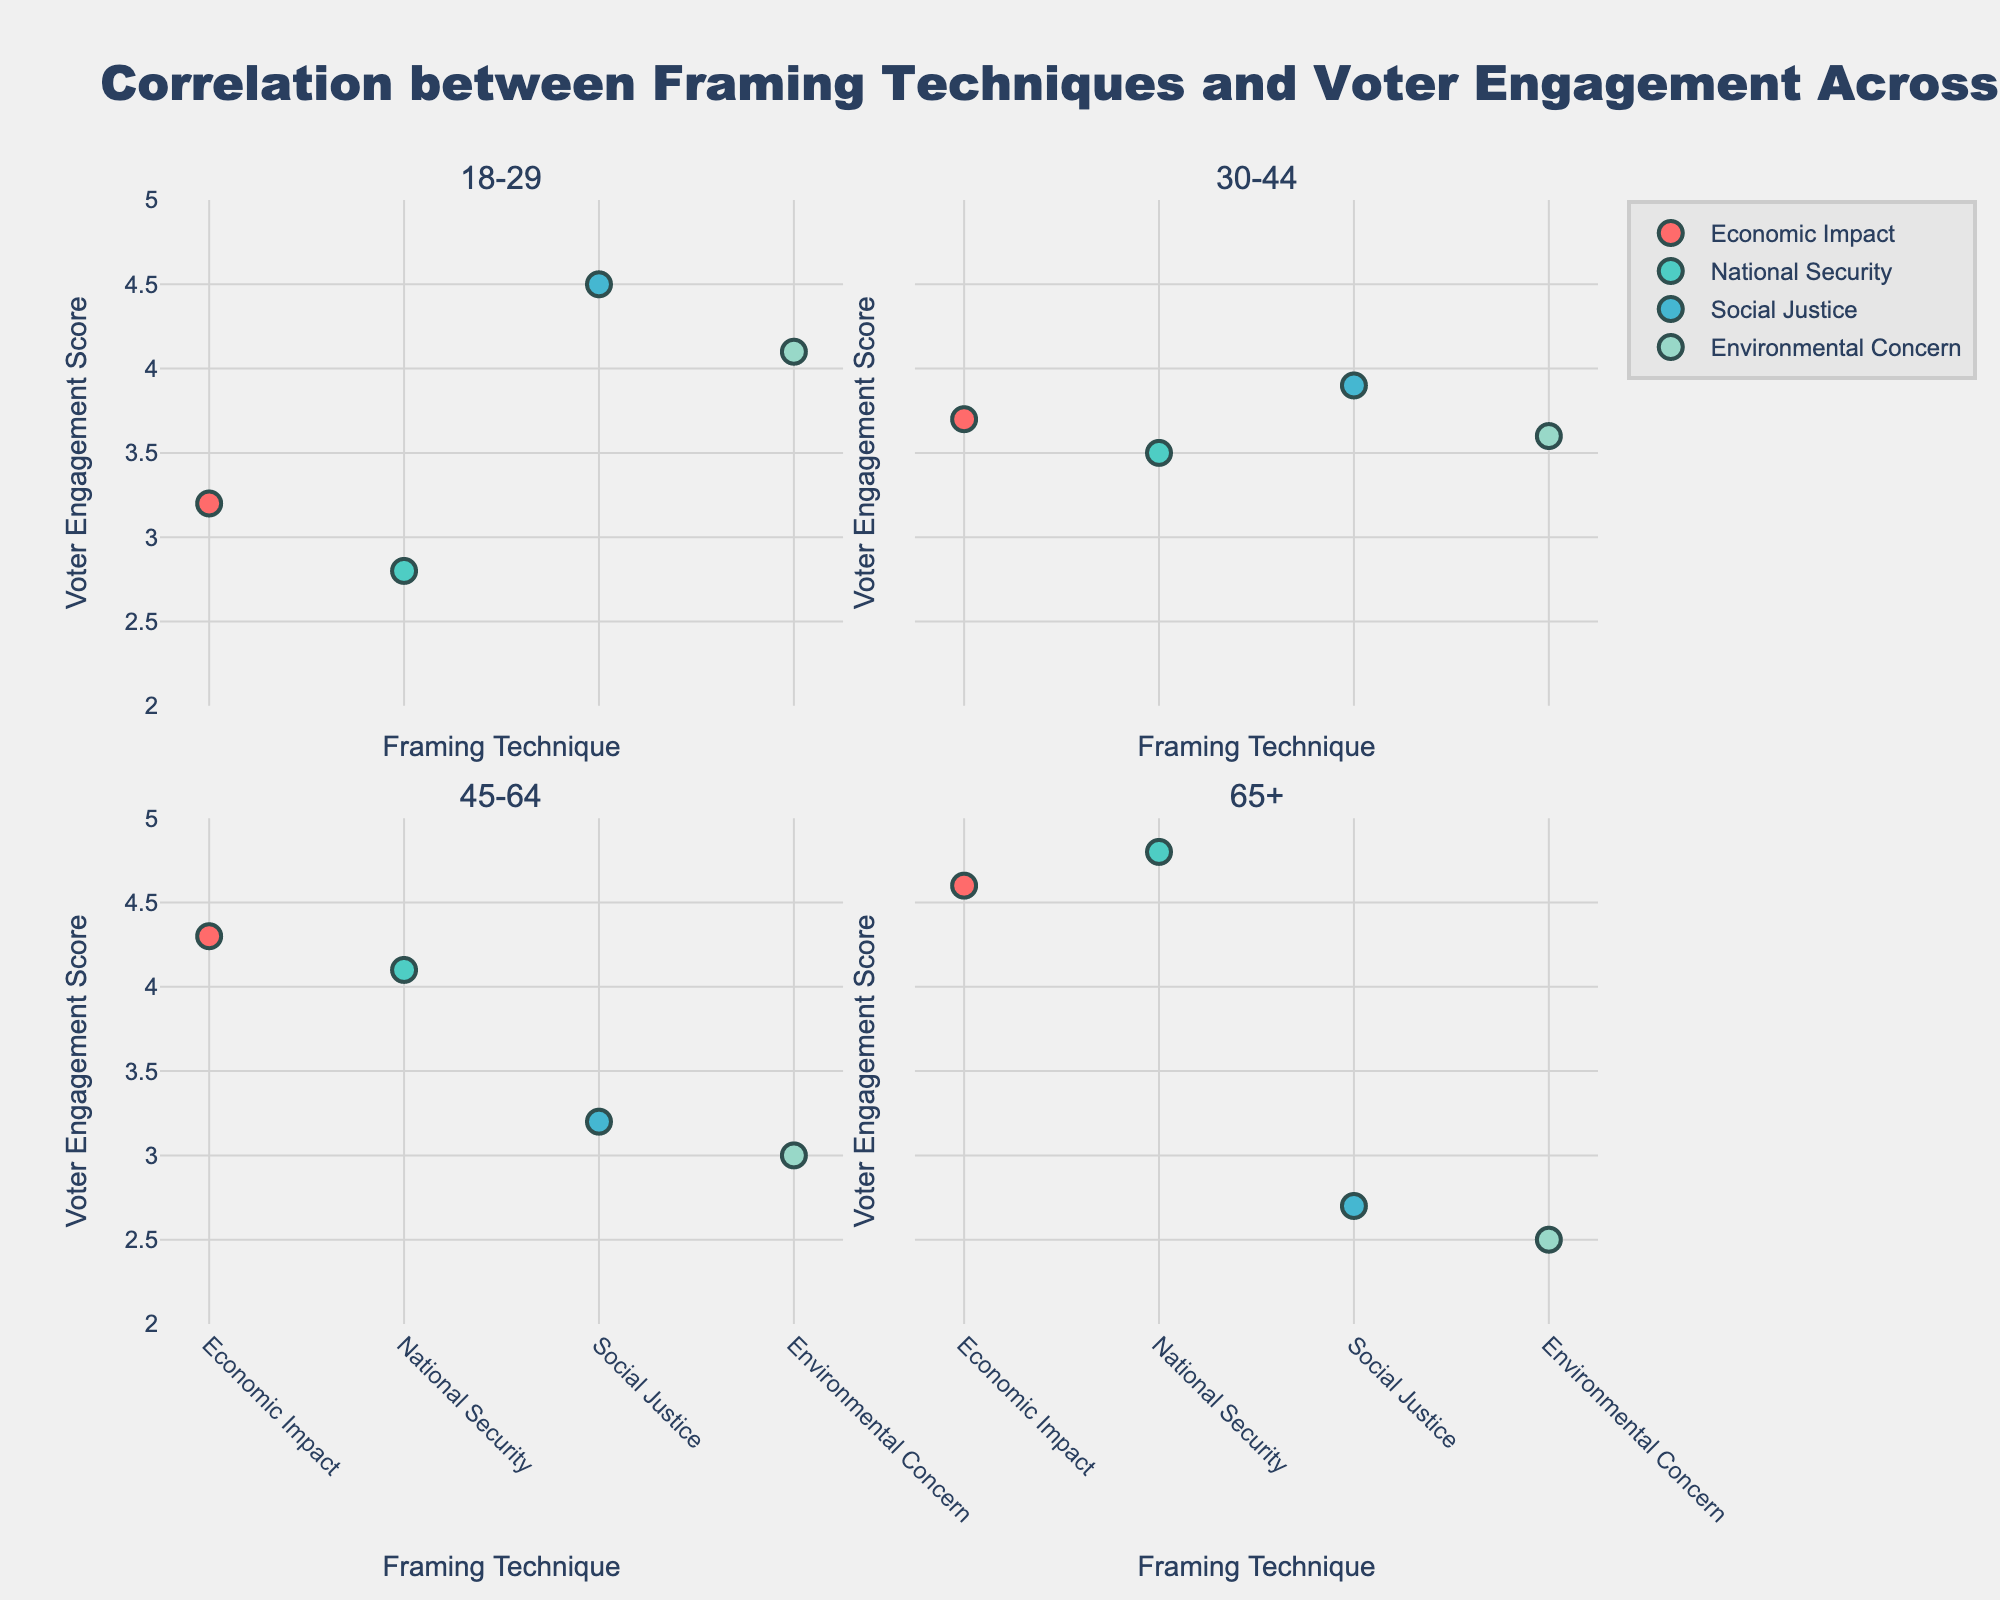what is the overall title of the plot? The title is clearly displayed at the top of the figure; it states the general theme of the visualization.
Answer: Correlation between Framing Techniques and Voter Engagement Across Age Groups What are the unique colors used in the scatter plots, and what do they represent? Each dot's color represents a different framing technique. There are four distinct colors, each associated with a different framing type.
Answer: Economic Impact is represented by red, National Security by turquoise, Social Justice by blue, Environmental Concern by light green Which age group has the highest average voter engagement score? Calculate the average voter engagement score for each age group by summing the scores for that age group and dividing by the number of techniques. Compare averages across age groups to determine the highest.
Answer: 65+ What is the voter engagement score for the 'Environmental Concern' technique in the 45-64 age group? Locate the subplot for the 45-64 age group and identify the 'Environmental Concern' marker. The y-axis value represents the voter engagement score.
Answer: 3.0 Which framing technique has the highest voter engagement score within the 18-29 age group? In the subplot for 18-29, observe which color reaches the highest point on the y-axis, indicating the highest engagement score.
Answer: Social Justice Compare the voter engagement scores for 'Economic Impact' between the 30-44 and 65+ age groups. Which one is higher? Find the 'Economic Impact' markers in both age groups' subplots. Compare their y-axis values to determine which is higher.
Answer: 65+ How does the voter engagement score for 'National Security' in the 30-44 age group compare to that in the 45-64 age group? Identify the 'National Security' markers in both age groups' subplots and compare their positions along the y-axis to see which is higher.
Answer: 45-64 What is the difference in voter engagement scores for 'Social Justice' between the 45-64 and 65+ age groups? Locate 'Social Justice' markers in both age groups' subplots and subtract the 65+ score from the 45-64 score.
Answer: 0.5 What framing technique has the lowest engagement score in the 65+ age group? Examine markers in the 65+ subplot and identify the color that is closest to the bottom of the y-axis.
Answer: Environmental Concern How do the engagement scores for 'Economic Impact' and 'Environmental Concern' compare within the 45-64 age group? Find both markers' positions in the 45-64 subplot and compare their heights on the y-axis.
Answer: Economic Impact is higher 